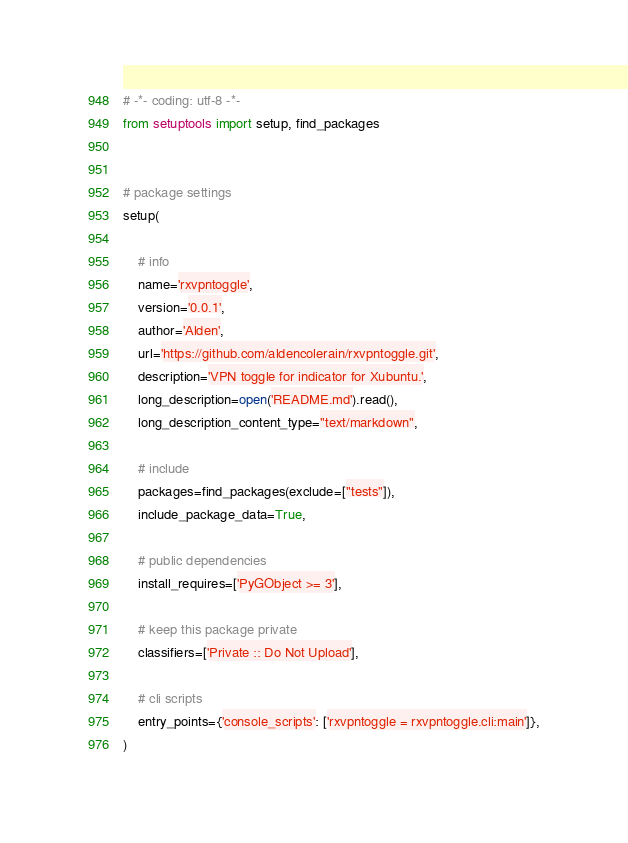Convert code to text. <code><loc_0><loc_0><loc_500><loc_500><_Python_># -*- coding: utf-8 -*-
from setuptools import setup, find_packages


# package settings
setup(

    # info
    name='rxvpntoggle',
    version='0.0.1',
    author='Alden',
    url='https://github.com/aldencolerain/rxvpntoggle.git',
    description='VPN toggle for indicator for Xubuntu.',
    long_description=open('README.md').read(),
    long_description_content_type="text/markdown",

    # include
    packages=find_packages(exclude=["tests"]),
    include_package_data=True,

    # public dependencies
    install_requires=['PyGObject >= 3'],

    # keep this package private
    classifiers=['Private :: Do Not Upload'],

    # cli scripts
    entry_points={'console_scripts': ['rxvpntoggle = rxvpntoggle.cli:main']},
)
</code> 